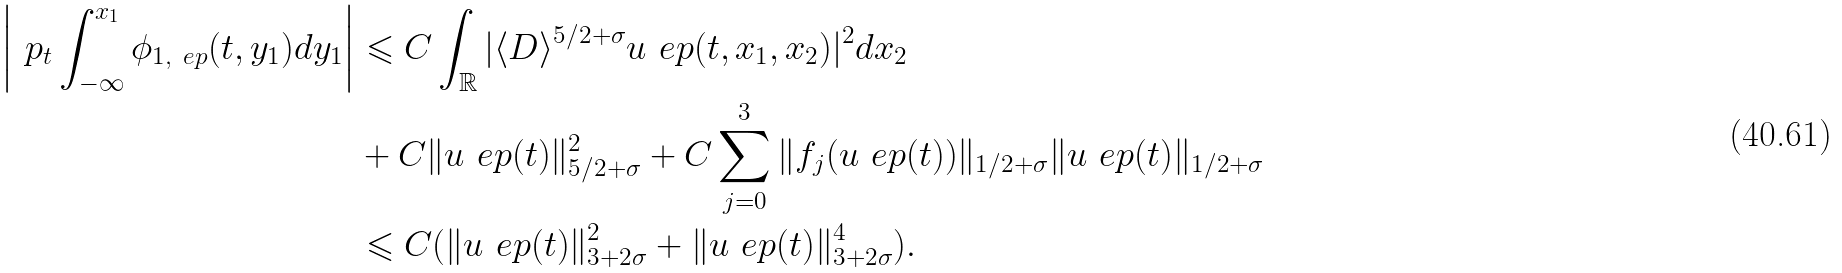Convert formula to latex. <formula><loc_0><loc_0><loc_500><loc_500>\left | \ p _ { t } \int _ { - \infty } ^ { x _ { 1 } } \phi _ { 1 , \ e p } ( t , y _ { 1 } ) d y _ { 1 } \right | & \leqslant C \int _ { \mathbb { R } } | \langle { D } \rangle ^ { 5 / 2 + \sigma } u _ { \ } e p ( t , x _ { 1 } , x _ { 2 } ) | ^ { 2 } d x _ { 2 } \\ & + C \| { u _ { \ } e p ( t ) } \| _ { 5 / 2 + \sigma } ^ { 2 } + C \sum _ { j = 0 } ^ { 3 } \| { f _ { j } ( u _ { \ } e p ( t ) ) } \| _ { 1 / 2 + \sigma } \| { u _ { \ } e p ( t ) } \| _ { 1 / 2 + \sigma } \\ & \leqslant C ( \| { u _ { \ } e p ( t ) } \| _ { 3 + 2 \sigma } ^ { 2 } + \| { u _ { \ } e p ( t ) } \| _ { 3 + 2 \sigma } ^ { 4 } ) .</formula> 